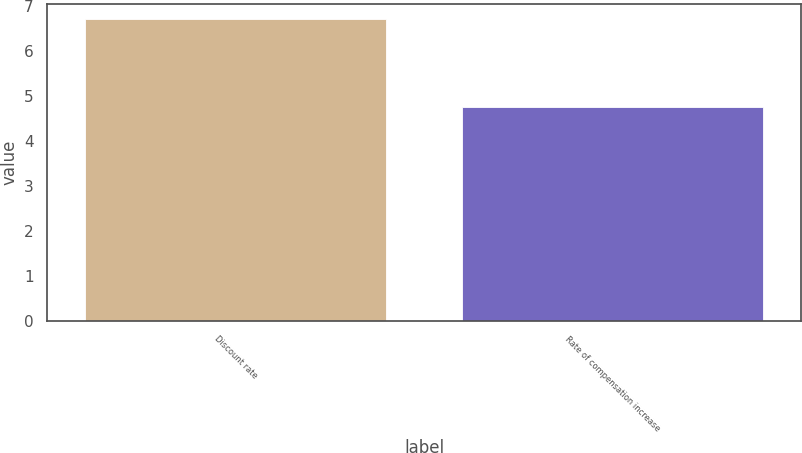Convert chart to OTSL. <chart><loc_0><loc_0><loc_500><loc_500><bar_chart><fcel>Discount rate<fcel>Rate of compensation increase<nl><fcel>6.7<fcel>4.75<nl></chart> 